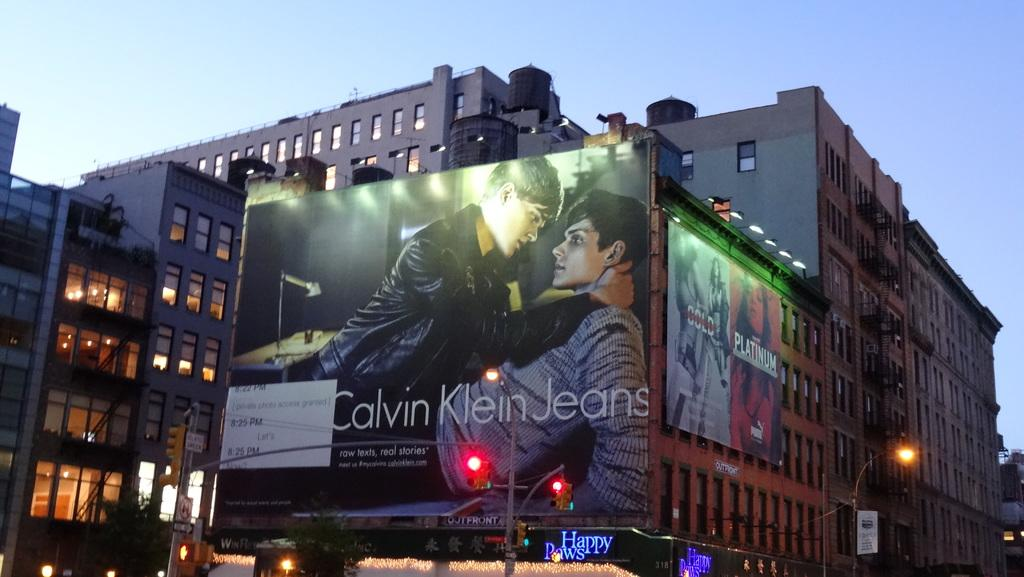<image>
Summarize the visual content of the image. Above a Happy Paws shop in the city is a huge Calvin Klein Jeans advertisement covering the entire side of the building. 